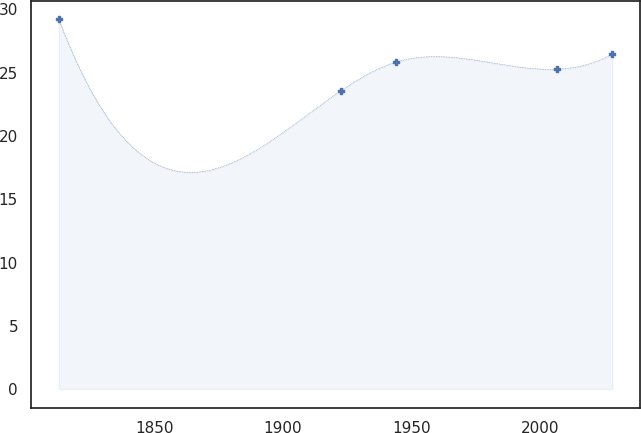Convert chart to OTSL. <chart><loc_0><loc_0><loc_500><loc_500><line_chart><ecel><fcel>Unnamed: 1<nl><fcel>1812.94<fcel>29.21<nl><fcel>1922.69<fcel>23.59<nl><fcel>1944.04<fcel>25.84<nl><fcel>2006.82<fcel>25.28<nl><fcel>2028.17<fcel>26.48<nl></chart> 